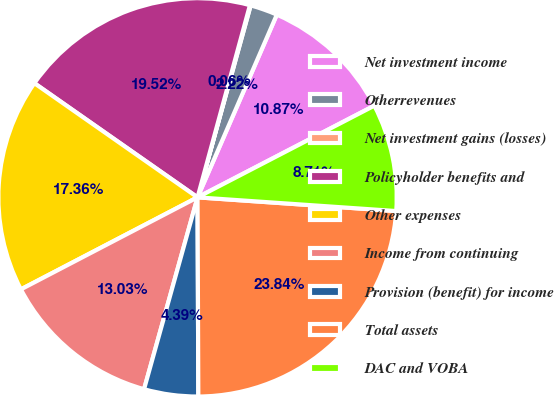<chart> <loc_0><loc_0><loc_500><loc_500><pie_chart><fcel>Net investment income<fcel>Otherrevenues<fcel>Net investment gains (losses)<fcel>Policyholder benefits and<fcel>Other expenses<fcel>Income from continuing<fcel>Provision (benefit) for income<fcel>Total assets<fcel>DAC and VOBA<nl><fcel>10.87%<fcel>2.22%<fcel>0.06%<fcel>19.52%<fcel>17.36%<fcel>13.03%<fcel>4.39%<fcel>23.84%<fcel>8.71%<nl></chart> 